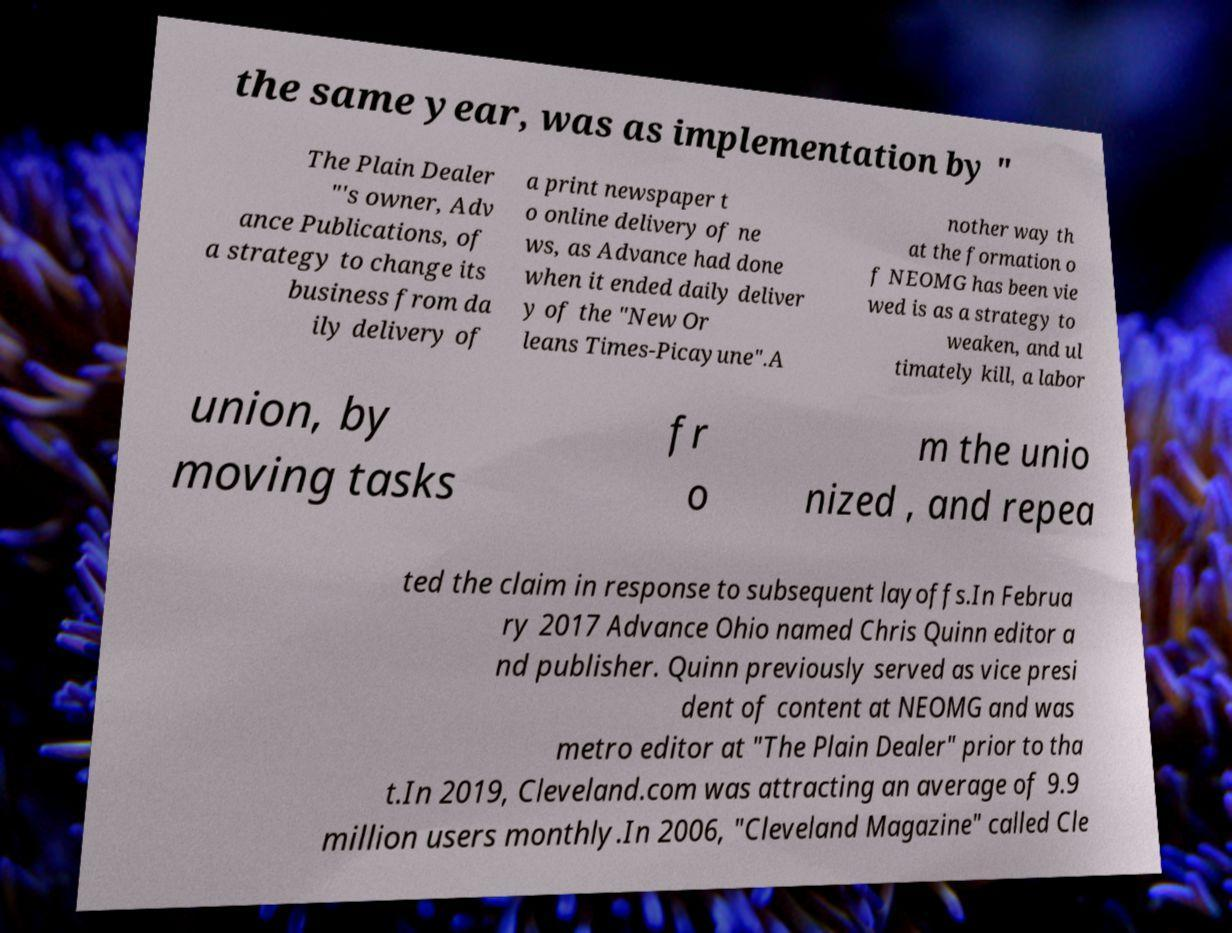Can you accurately transcribe the text from the provided image for me? the same year, was as implementation by " The Plain Dealer "'s owner, Adv ance Publications, of a strategy to change its business from da ily delivery of a print newspaper t o online delivery of ne ws, as Advance had done when it ended daily deliver y of the "New Or leans Times-Picayune".A nother way th at the formation o f NEOMG has been vie wed is as a strategy to weaken, and ul timately kill, a labor union, by moving tasks fr o m the unio nized , and repea ted the claim in response to subsequent layoffs.In Februa ry 2017 Advance Ohio named Chris Quinn editor a nd publisher. Quinn previously served as vice presi dent of content at NEOMG and was metro editor at "The Plain Dealer" prior to tha t.In 2019, Cleveland.com was attracting an average of 9.9 million users monthly.In 2006, "Cleveland Magazine" called Cle 